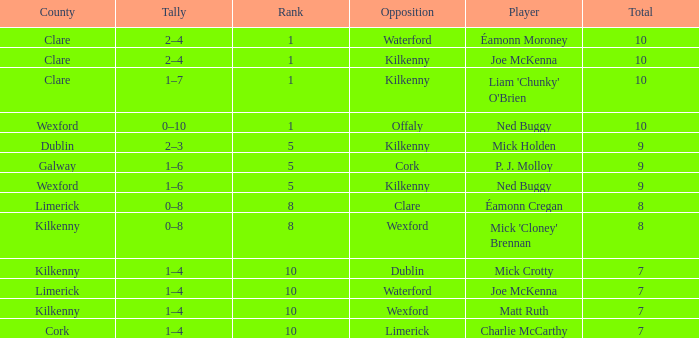Which County has a Rank larger than 8, and a Player of joe mckenna? Limerick. 